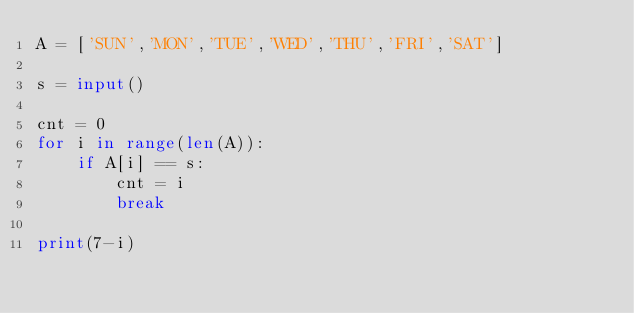<code> <loc_0><loc_0><loc_500><loc_500><_Python_>A = ['SUN','MON','TUE','WED','THU','FRI','SAT']

s = input()

cnt = 0
for i in range(len(A)):
    if A[i] == s:
        cnt = i
        break

print(7-i)
</code> 